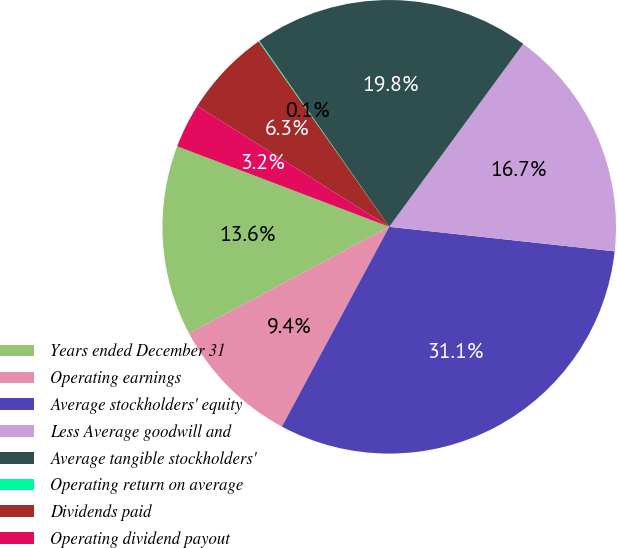<chart> <loc_0><loc_0><loc_500><loc_500><pie_chart><fcel>Years ended December 31<fcel>Operating earnings<fcel>Average stockholders' equity<fcel>Less Average goodwill and<fcel>Average tangible stockholders'<fcel>Operating return on average<fcel>Dividends paid<fcel>Operating dividend payout<nl><fcel>13.55%<fcel>9.38%<fcel>31.12%<fcel>16.66%<fcel>19.77%<fcel>0.07%<fcel>6.28%<fcel>3.17%<nl></chart> 